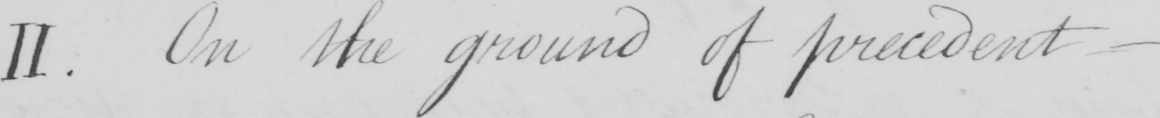Transcribe the text shown in this historical manuscript line. II . On the ground of precedent  _ 